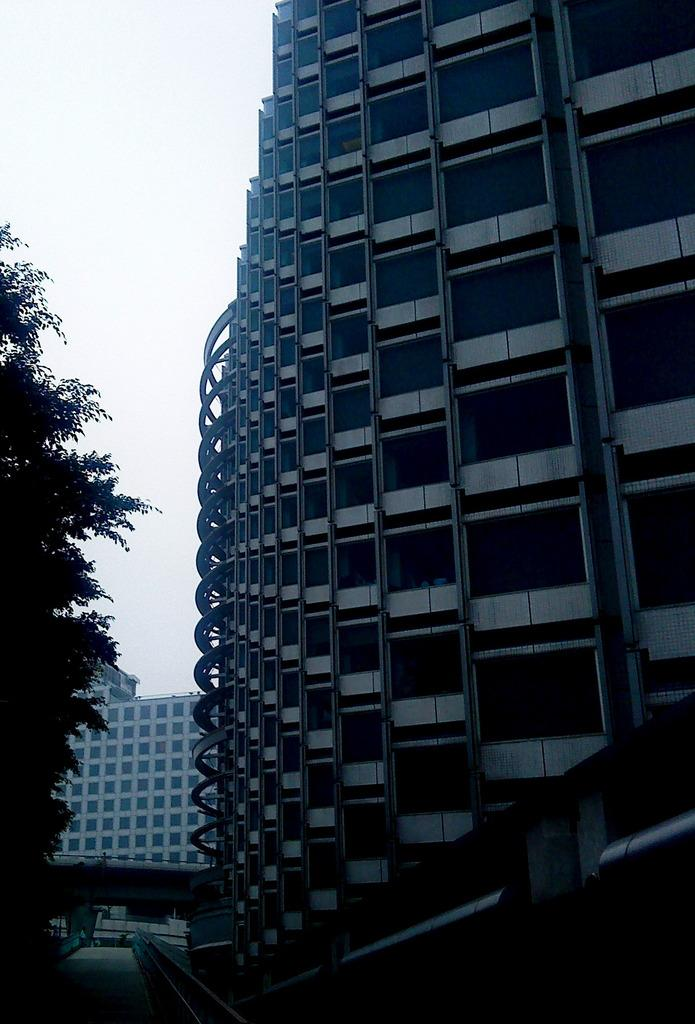What type of structures are present in the image? There are buildings in the image. What type of vegetation is present in the image? There is a tree in the image. What can be seen in the background of the image? The sky is visible in the background of the image. What color is the string tied around the tree in the image? There is no string tied around the tree in the image. What type of beetle can be seen crawling on the buildings in the image? There are no beetles present in the image. 